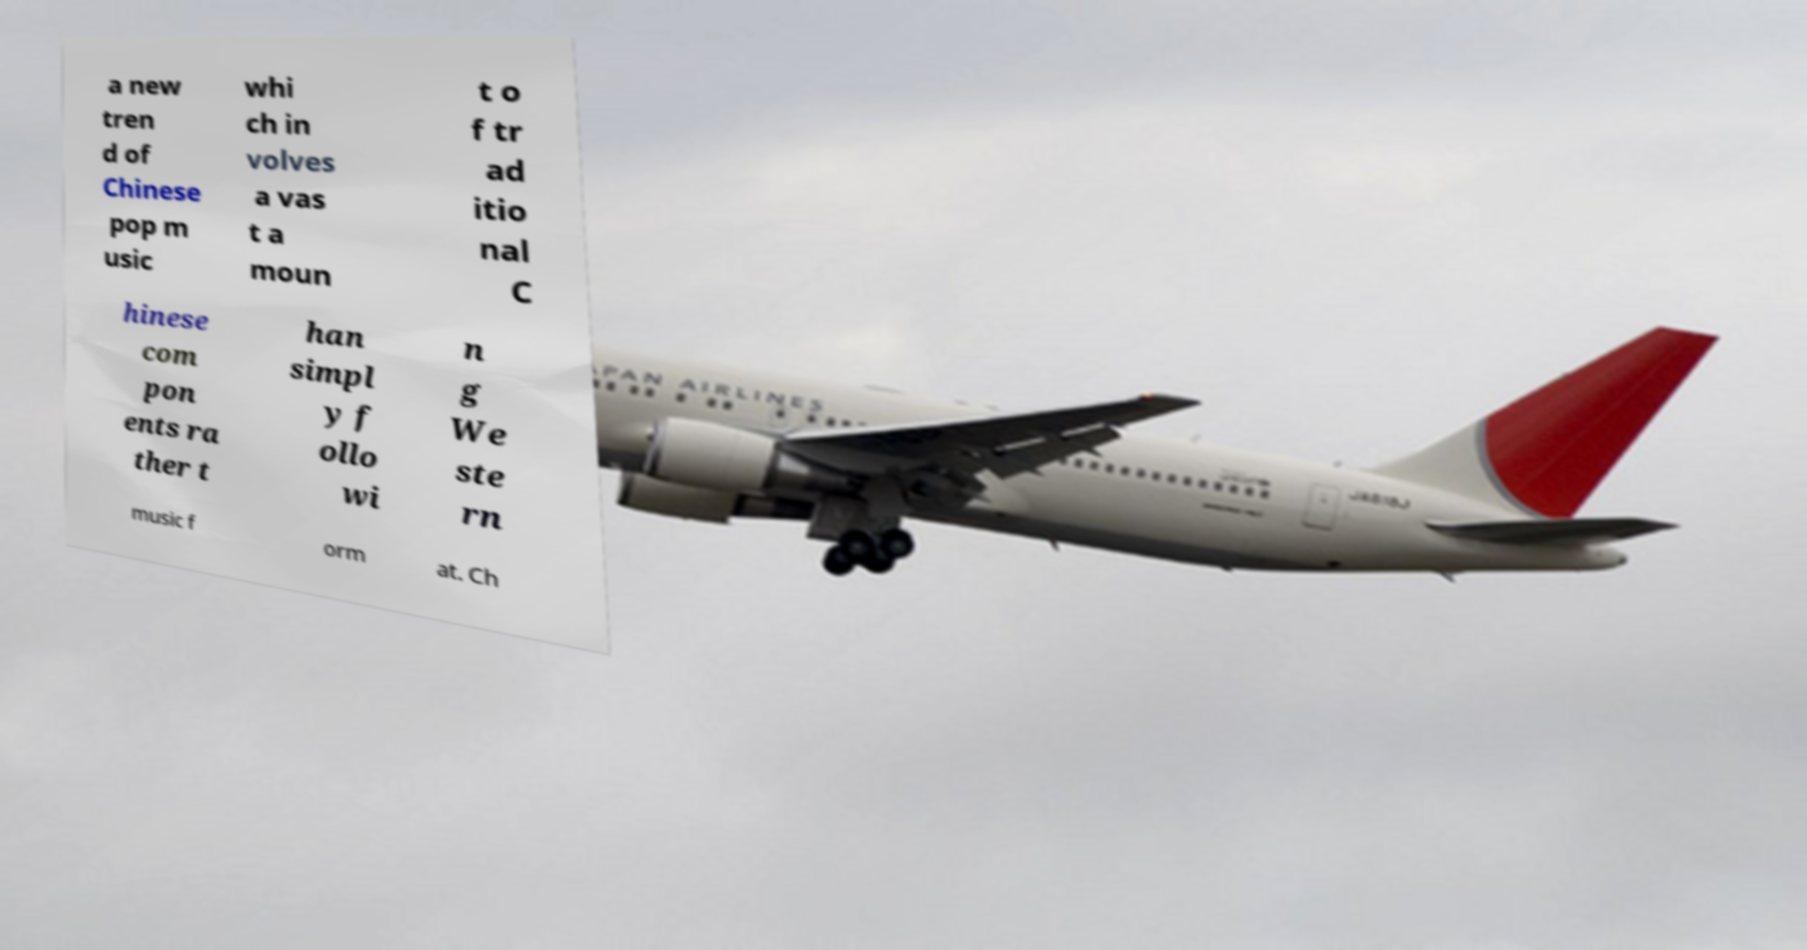Can you read and provide the text displayed in the image?This photo seems to have some interesting text. Can you extract and type it out for me? a new tren d of Chinese pop m usic whi ch in volves a vas t a moun t o f tr ad itio nal C hinese com pon ents ra ther t han simpl y f ollo wi n g We ste rn music f orm at. Ch 